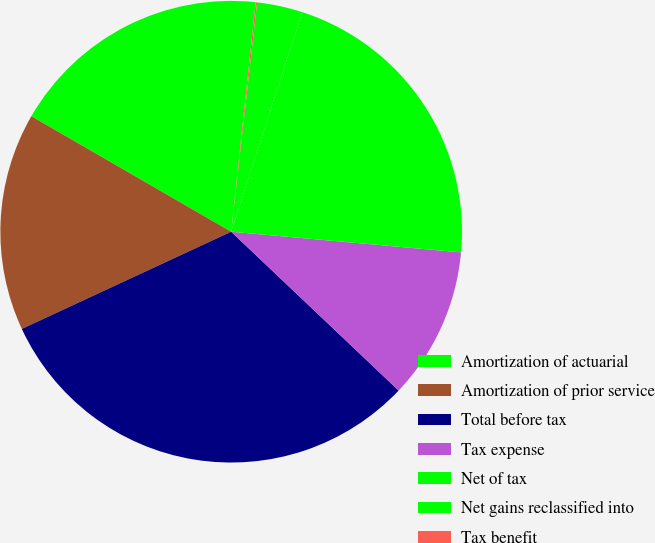<chart> <loc_0><loc_0><loc_500><loc_500><pie_chart><fcel>Amortization of actuarial<fcel>Amortization of prior service<fcel>Total before tax<fcel>Tax expense<fcel>Net of tax<fcel>Net gains reclassified into<fcel>Tax benefit<nl><fcel>18.35%<fcel>15.26%<fcel>31.0%<fcel>10.65%<fcel>21.44%<fcel>3.19%<fcel>0.1%<nl></chart> 